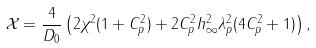<formula> <loc_0><loc_0><loc_500><loc_500>\mathcal { X } = \frac { 4 } { D _ { 0 } } \left ( 2 \chi ^ { 2 } ( 1 + C _ { p } ^ { 2 } ) + 2 C _ { p } ^ { 2 } h _ { \infty } ^ { 2 } \lambda _ { p } ^ { 2 } ( 4 C _ { p } ^ { 2 } + 1 ) \right ) ,</formula> 